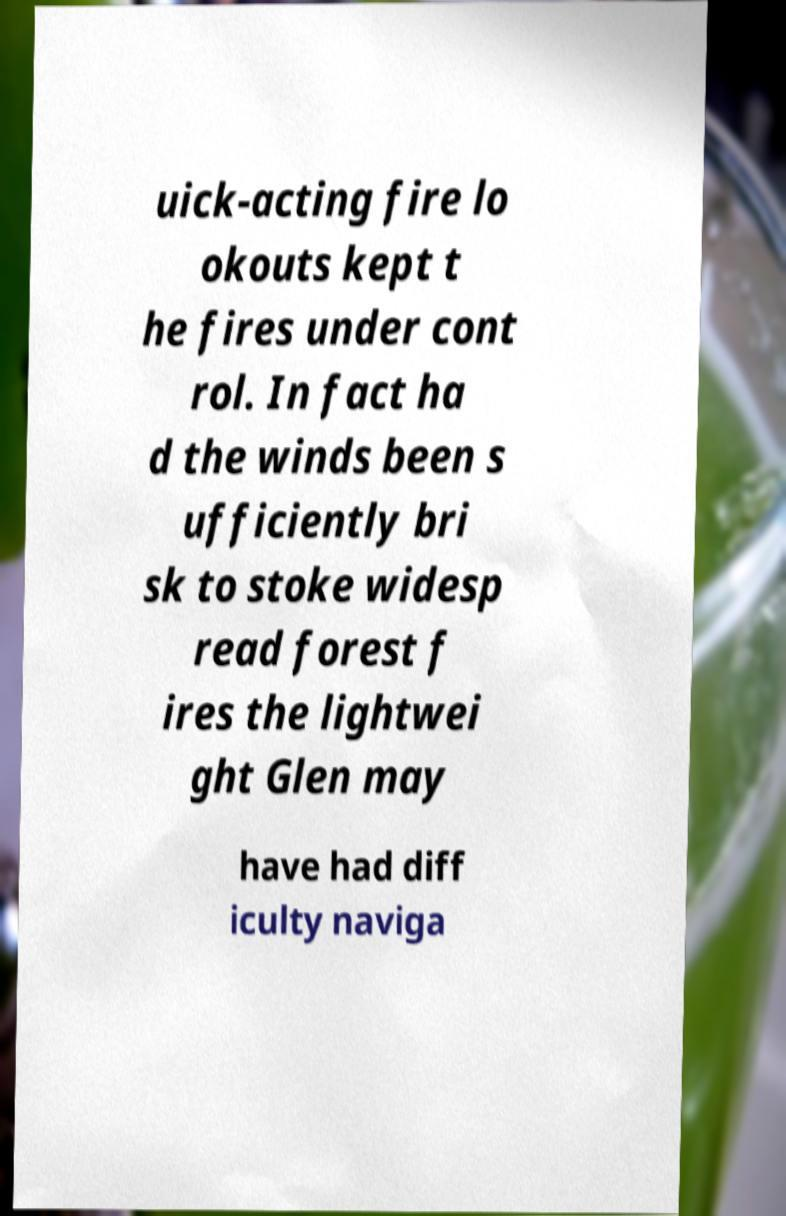There's text embedded in this image that I need extracted. Can you transcribe it verbatim? uick-acting fire lo okouts kept t he fires under cont rol. In fact ha d the winds been s ufficiently bri sk to stoke widesp read forest f ires the lightwei ght Glen may have had diff iculty naviga 